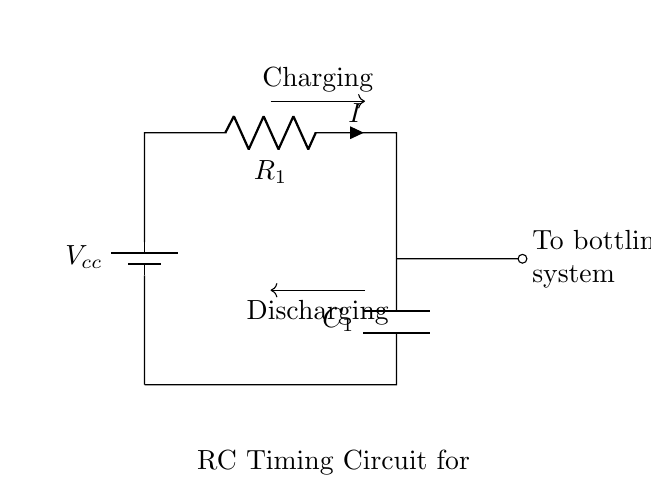What is the voltage source in this circuit? The voltage source is labeled as Vcc in the diagram, which provides the necessary potential difference for the circuit to function.
Answer: Vcc What is the value of the resistor in the circuit? The resistor is labeled as R1 in the diagram. The specific value is not provided, but it is clearly marked on the circuit.
Answer: R1 What is the primary function of the capacitor in this circuit? The capacitor, C1, is used to store charge, which enables timing behavior by charging and discharging in relation to the resistor, affecting how long the circuit takes to respond.
Answer: Timing What happens to the current during the charging phase? During the charging phase, current flows from Vcc through R1 into C1, allowing the capacitor to accumulate charge until it reaches a certain voltage level.
Answer: Increases How does the capacitor affect the timing of the bottling system? The timing is determined by the RC time constant, which is the product of resistance (R1) and capacitance (C1). This time constant dictates how long it takes for the capacitor to charge to approximately 63% of Vcc, influencing the operational timing of the system.
Answer: RC time constant What occurs during the discharging phase of the capacitor? During the discharging phase, the stored energy in C1 is released, allowing current to flow back into the circuit through R1, which provides a reset mechanism for the timer, ensuring that the bottling process can commence after a defined duration.
Answer: Releases energy 